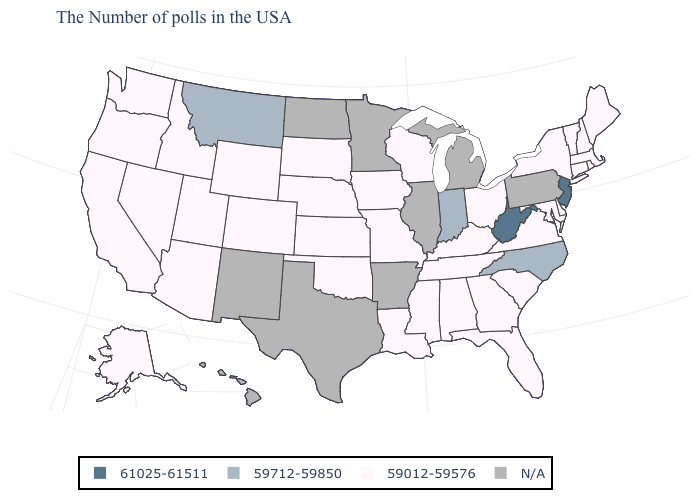Name the states that have a value in the range 59712-59850?
Answer briefly. North Carolina, Indiana, Montana. What is the value of New Mexico?
Keep it brief. N/A. What is the value of Florida?
Short answer required. 59012-59576. What is the lowest value in states that border New Jersey?
Quick response, please. 59012-59576. Which states have the highest value in the USA?
Give a very brief answer. New Jersey, West Virginia. Name the states that have a value in the range 59012-59576?
Write a very short answer. Maine, Massachusetts, Rhode Island, New Hampshire, Vermont, Connecticut, New York, Delaware, Maryland, Virginia, South Carolina, Ohio, Florida, Georgia, Kentucky, Alabama, Tennessee, Wisconsin, Mississippi, Louisiana, Missouri, Iowa, Kansas, Nebraska, Oklahoma, South Dakota, Wyoming, Colorado, Utah, Arizona, Idaho, Nevada, California, Washington, Oregon, Alaska. What is the highest value in the USA?
Be succinct. 61025-61511. Name the states that have a value in the range 59712-59850?
Short answer required. North Carolina, Indiana, Montana. What is the highest value in states that border North Dakota?
Answer briefly. 59712-59850. What is the lowest value in the USA?
Concise answer only. 59012-59576. What is the lowest value in the West?
Give a very brief answer. 59012-59576. What is the value of Idaho?
Be succinct. 59012-59576. Among the states that border New York , does Vermont have the lowest value?
Concise answer only. Yes. 